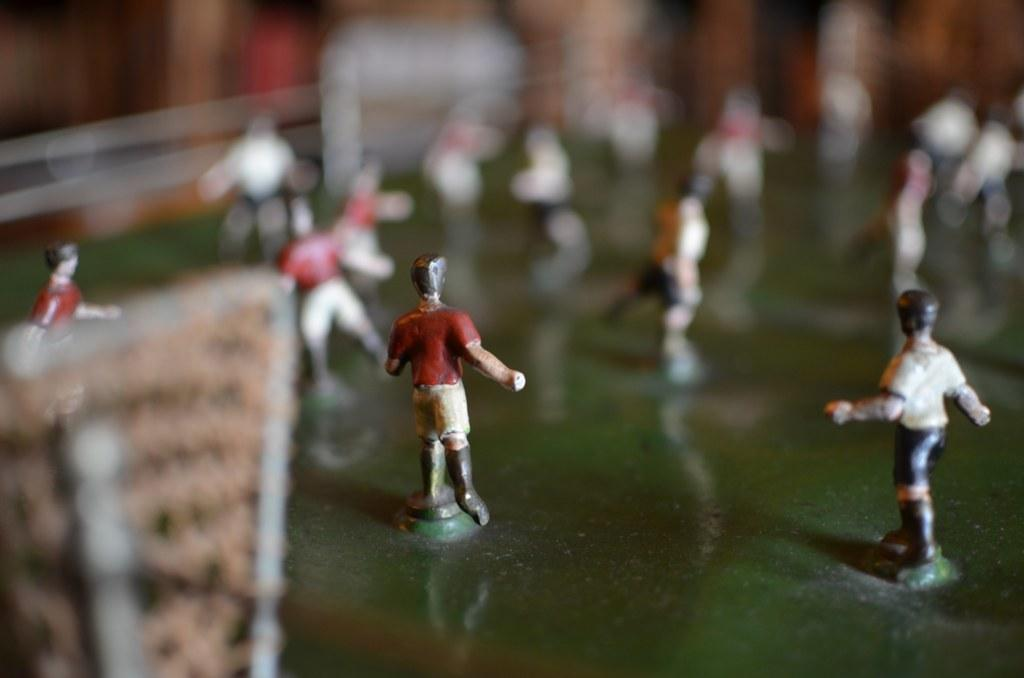What is the main subject of the image? There is a miniature in the image. Where is the building located in the image? The building is on the left side of the image. How would you describe the background of the image? The background of the image appears blurred. What type of stew is being served at the event in the image? There is no event or stew present in the image; it features a miniature and a building. Which team is participating in the competition in the image? There is no competition or team present in the image. 